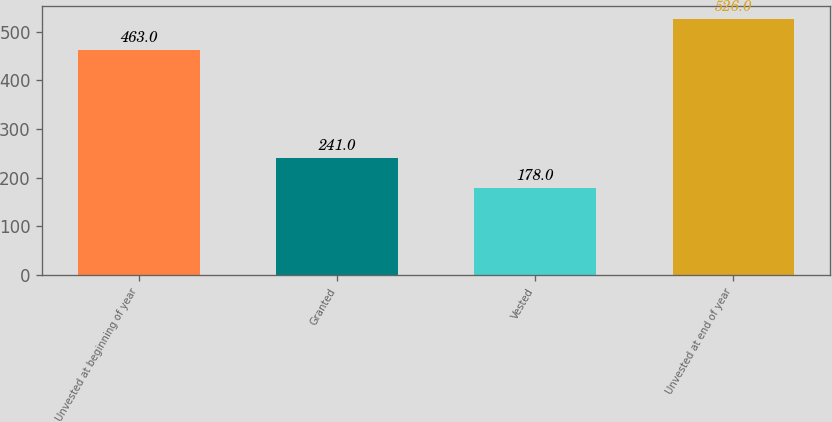<chart> <loc_0><loc_0><loc_500><loc_500><bar_chart><fcel>Unvested at beginning of year<fcel>Granted<fcel>Vested<fcel>Unvested at end of year<nl><fcel>463<fcel>241<fcel>178<fcel>526<nl></chart> 